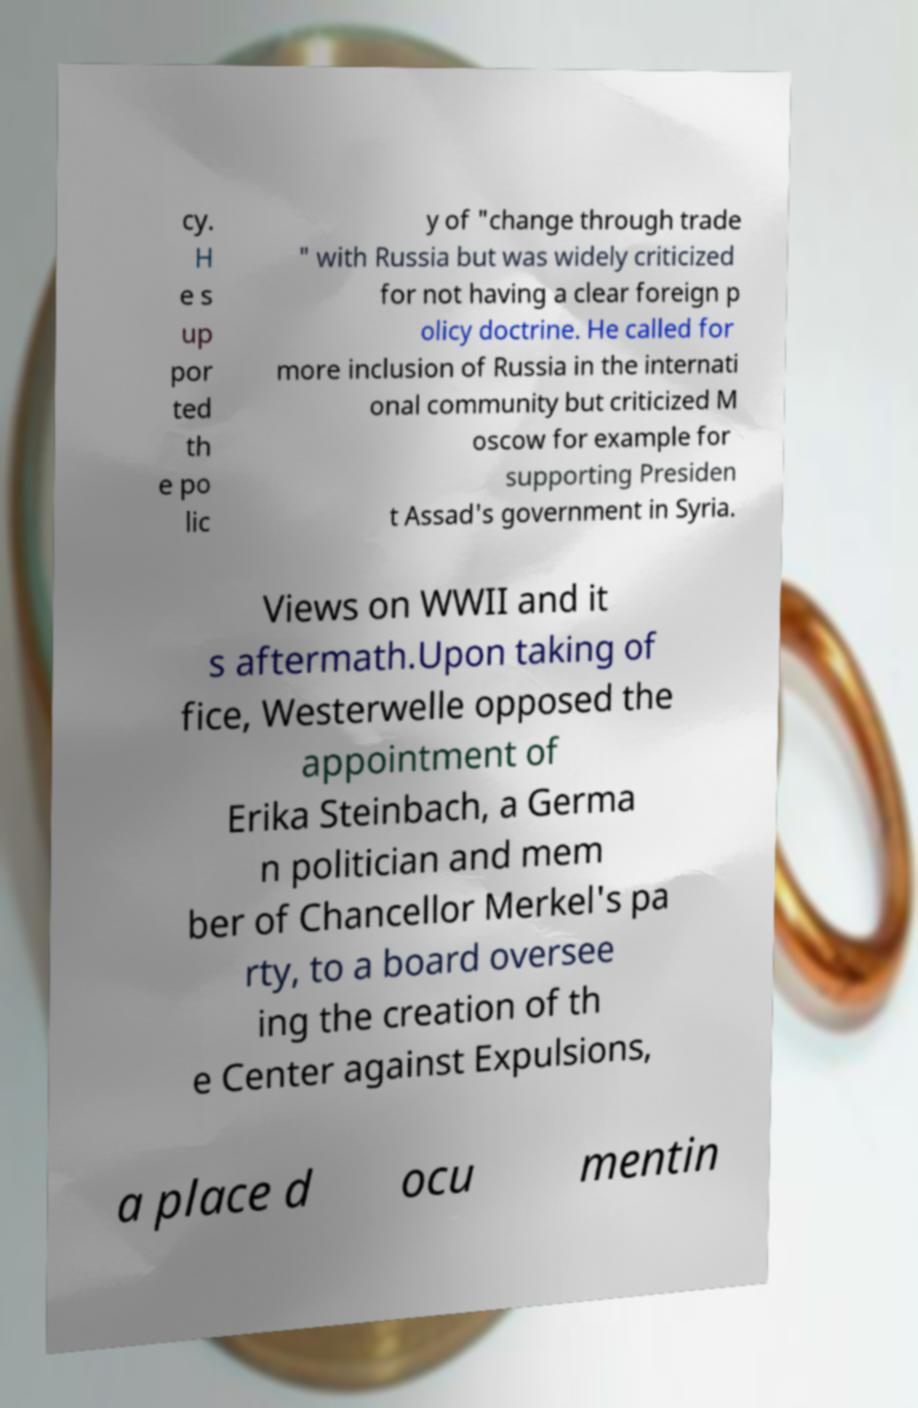Can you accurately transcribe the text from the provided image for me? cy. H e s up por ted th e po lic y of "change through trade " with Russia but was widely criticized for not having a clear foreign p olicy doctrine. He called for more inclusion of Russia in the internati onal community but criticized M oscow for example for supporting Presiden t Assad's government in Syria. Views on WWII and it s aftermath.Upon taking of fice, Westerwelle opposed the appointment of Erika Steinbach, a Germa n politician and mem ber of Chancellor Merkel's pa rty, to a board oversee ing the creation of th e Center against Expulsions, a place d ocu mentin 